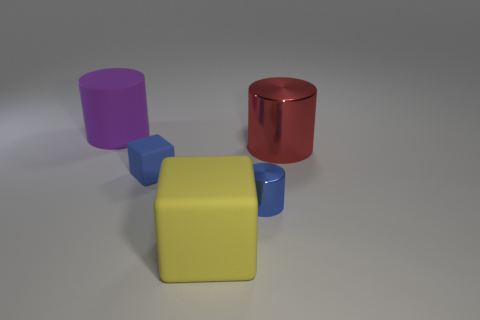Subtract all big metal cylinders. How many cylinders are left? 2 Add 4 red rubber blocks. How many objects exist? 9 Subtract all red cylinders. How many cylinders are left? 2 Subtract 0 cyan cylinders. How many objects are left? 5 Subtract all cylinders. How many objects are left? 2 Subtract all gray blocks. Subtract all red cylinders. How many blocks are left? 2 Subtract all blue cylinders. How many red cubes are left? 0 Subtract all big matte things. Subtract all blue cylinders. How many objects are left? 2 Add 5 yellow cubes. How many yellow cubes are left? 6 Add 1 green blocks. How many green blocks exist? 1 